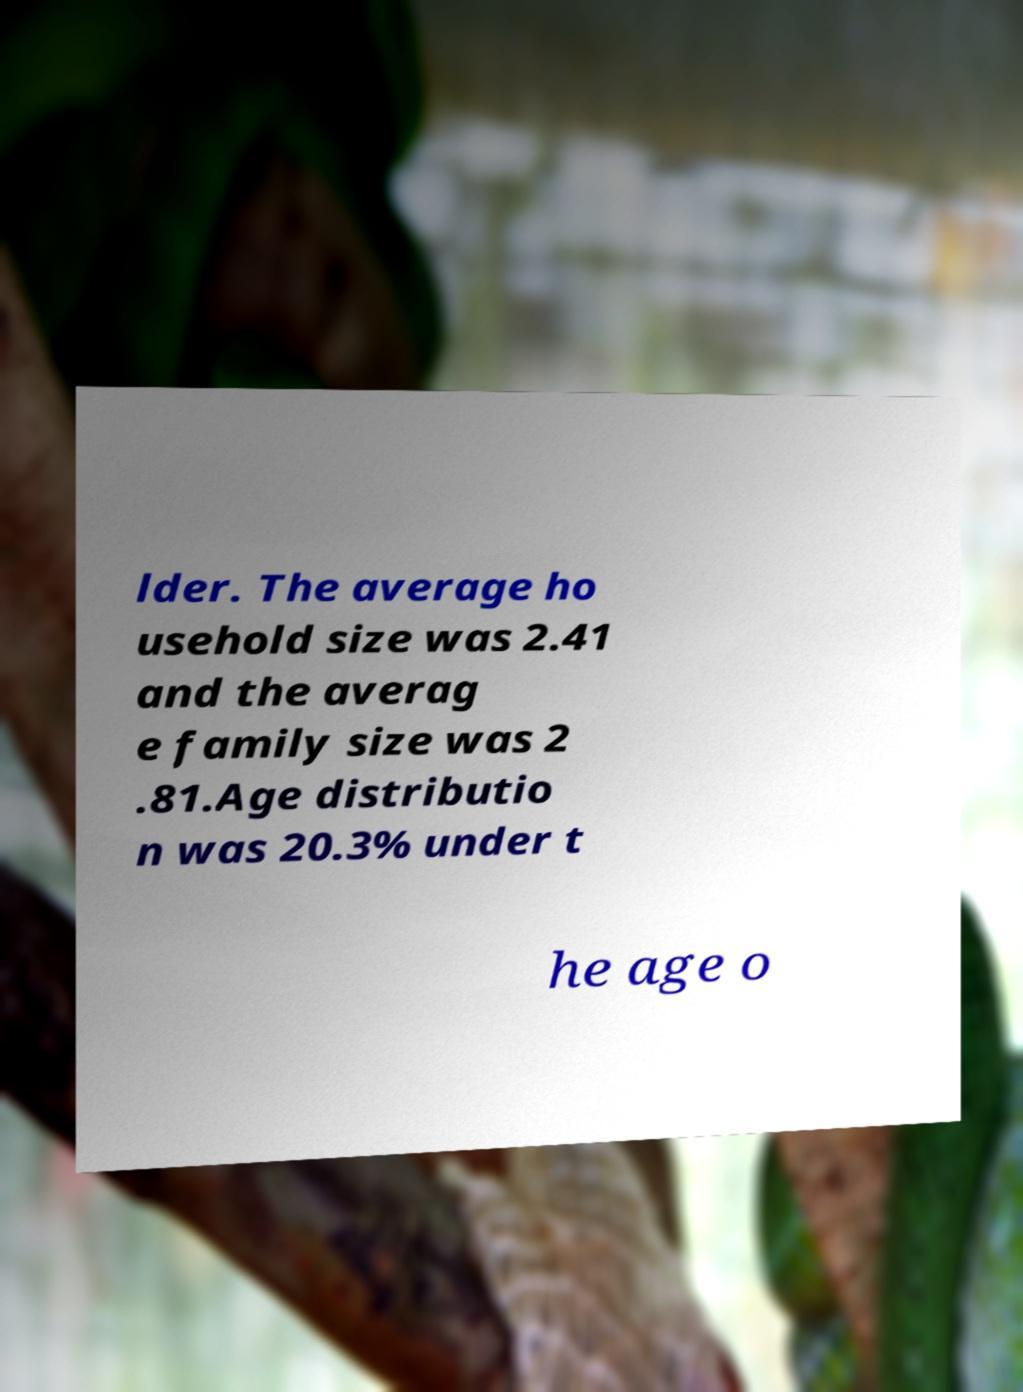Can you read and provide the text displayed in the image?This photo seems to have some interesting text. Can you extract and type it out for me? lder. The average ho usehold size was 2.41 and the averag e family size was 2 .81.Age distributio n was 20.3% under t he age o 